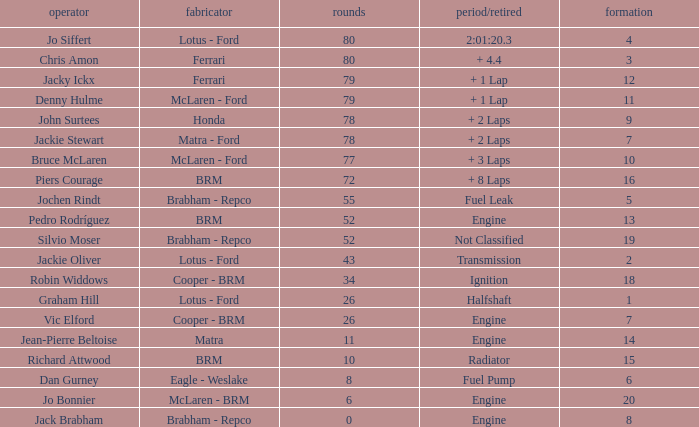What driver has a grid greater than 19? Jo Bonnier. 